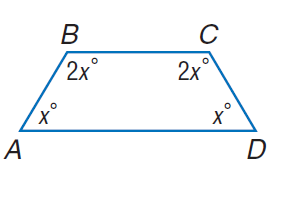Answer the mathemtical geometry problem and directly provide the correct option letter.
Question: Find m \angle C.
Choices: A: 30 B: 60 C: 90 D: 120 D 